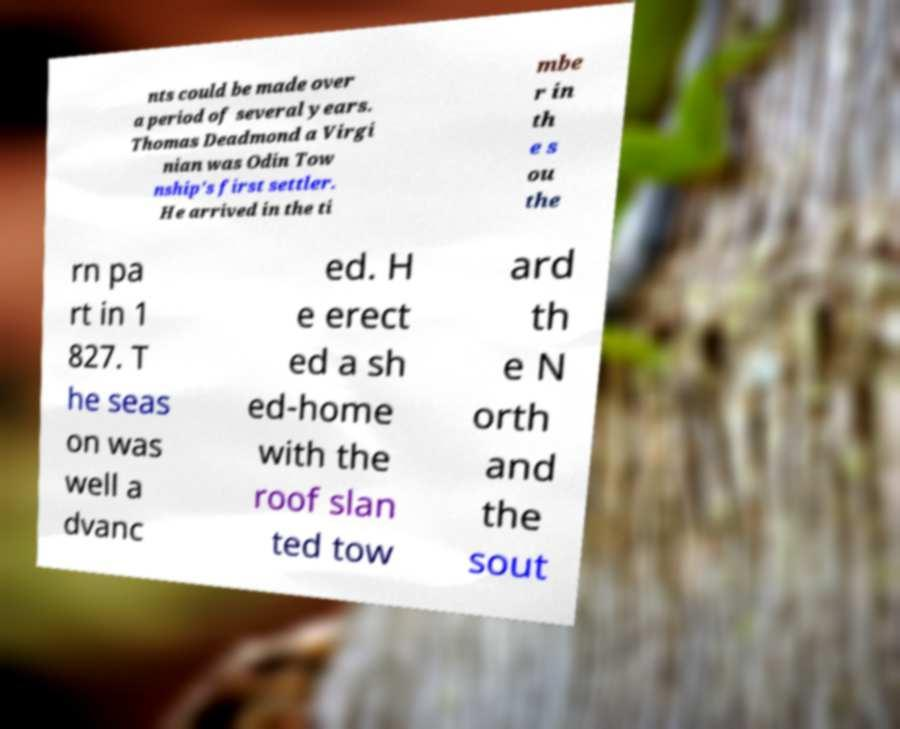Could you assist in decoding the text presented in this image and type it out clearly? nts could be made over a period of several years. Thomas Deadmond a Virgi nian was Odin Tow nship's first settler. He arrived in the ti mbe r in th e s ou the rn pa rt in 1 827. T he seas on was well a dvanc ed. H e erect ed a sh ed-home with the roof slan ted tow ard th e N orth and the sout 